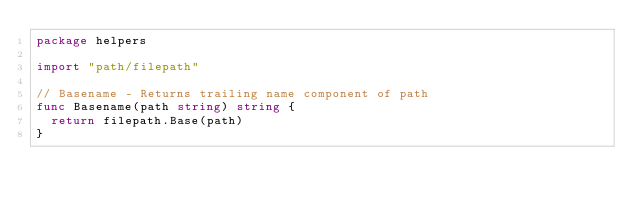Convert code to text. <code><loc_0><loc_0><loc_500><loc_500><_Go_>package helpers

import "path/filepath"

// Basename - Returns trailing name component of path
func Basename(path string) string {
	return filepath.Base(path)
}</code> 